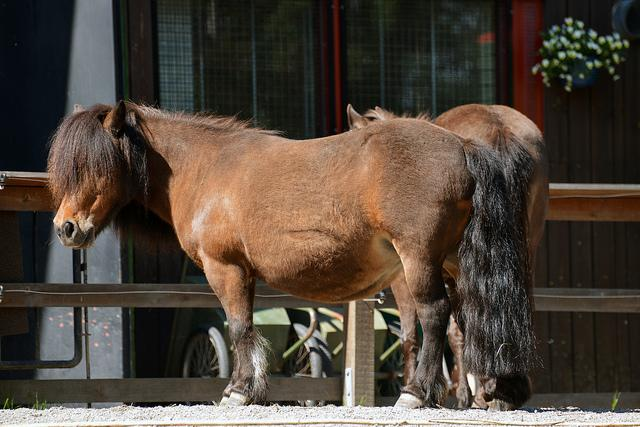What type of horse is this? Please explain your reasoning. shetland pony. This is a type of pony. 